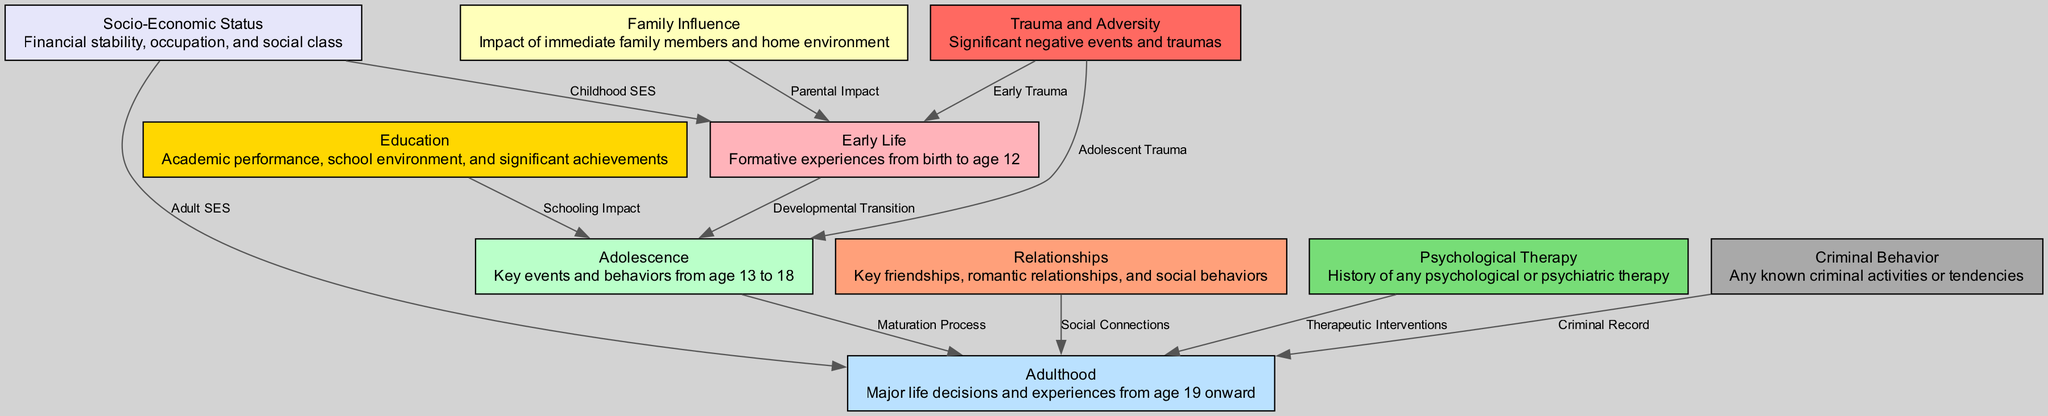What are the main life stages represented in the diagram? The diagram includes nodes for Early Life, Adolescence, and Adulthood, representing the main developmental stages.
Answer: Early Life, Adolescence, Adulthood How many nodes are there in total? The diagram contains 10 nodes that each represent different aspects of subject background analysis.
Answer: 10 What is the relationship labeled between Early Life and Adolescence? The diagram labels the relationship between Early Life and Adolescence as "Developmental Transition" indicating the progression from one stage to the next.
Answer: Developmental Transition Which node directly influences the Adulthood stage regarding therapy? The node labeled "Psychological Therapy" has a direct edge leading to "Adulthood," indicating its influence during this life stage.
Answer: Psychological Therapy How does Trauma relate to Early Life and Adolescence? The diagram shows that Trauma has edges leading to both Early Life and Adolescence, labelled as "Early Trauma" and "Adolescent Trauma," indicating its impact during these formative years.
Answer: Early Trauma, Adolescent Trauma What type of influence is documented from Family Influence to Early Life? The diagram labels the influence from Family Influence to Early Life as "Parental Impact," which represents the role of family on development at this stage.
Answer: Parental Impact In how many instances does Socio-Economic Status influence the diagram? Socio-Economic Status influences the diagram in two instances - once in Early Life (Childhood SES) and once in Adulthood (Adult SES).
Answer: 2 What label connects Education to Adolescence? The relationship between Education and Adolescence is labeled as "Schooling Impact," which highlights how educational experiences shape behavior during this stage.
Answer: Schooling Impact What is the primary impact of relationships on Adulthood? Relationships have a direct effect on Adulthood, indicated as "Social Connections," suggesting the importance of social ties at this stage in life.
Answer: Social Connections How are criminal behaviors represented in relation to Adulthood? Criminal behavior is represented in the diagram as having a direct edge to Adulthood, labeled "Criminal Record," indicating its influence after the formative years.
Answer: Criminal Record 